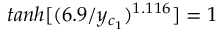Convert formula to latex. <formula><loc_0><loc_0><loc_500><loc_500>t a n h [ ( 6 . 9 / y _ { c _ { 1 } } ) ^ { 1 . 1 1 6 } ] = 1</formula> 